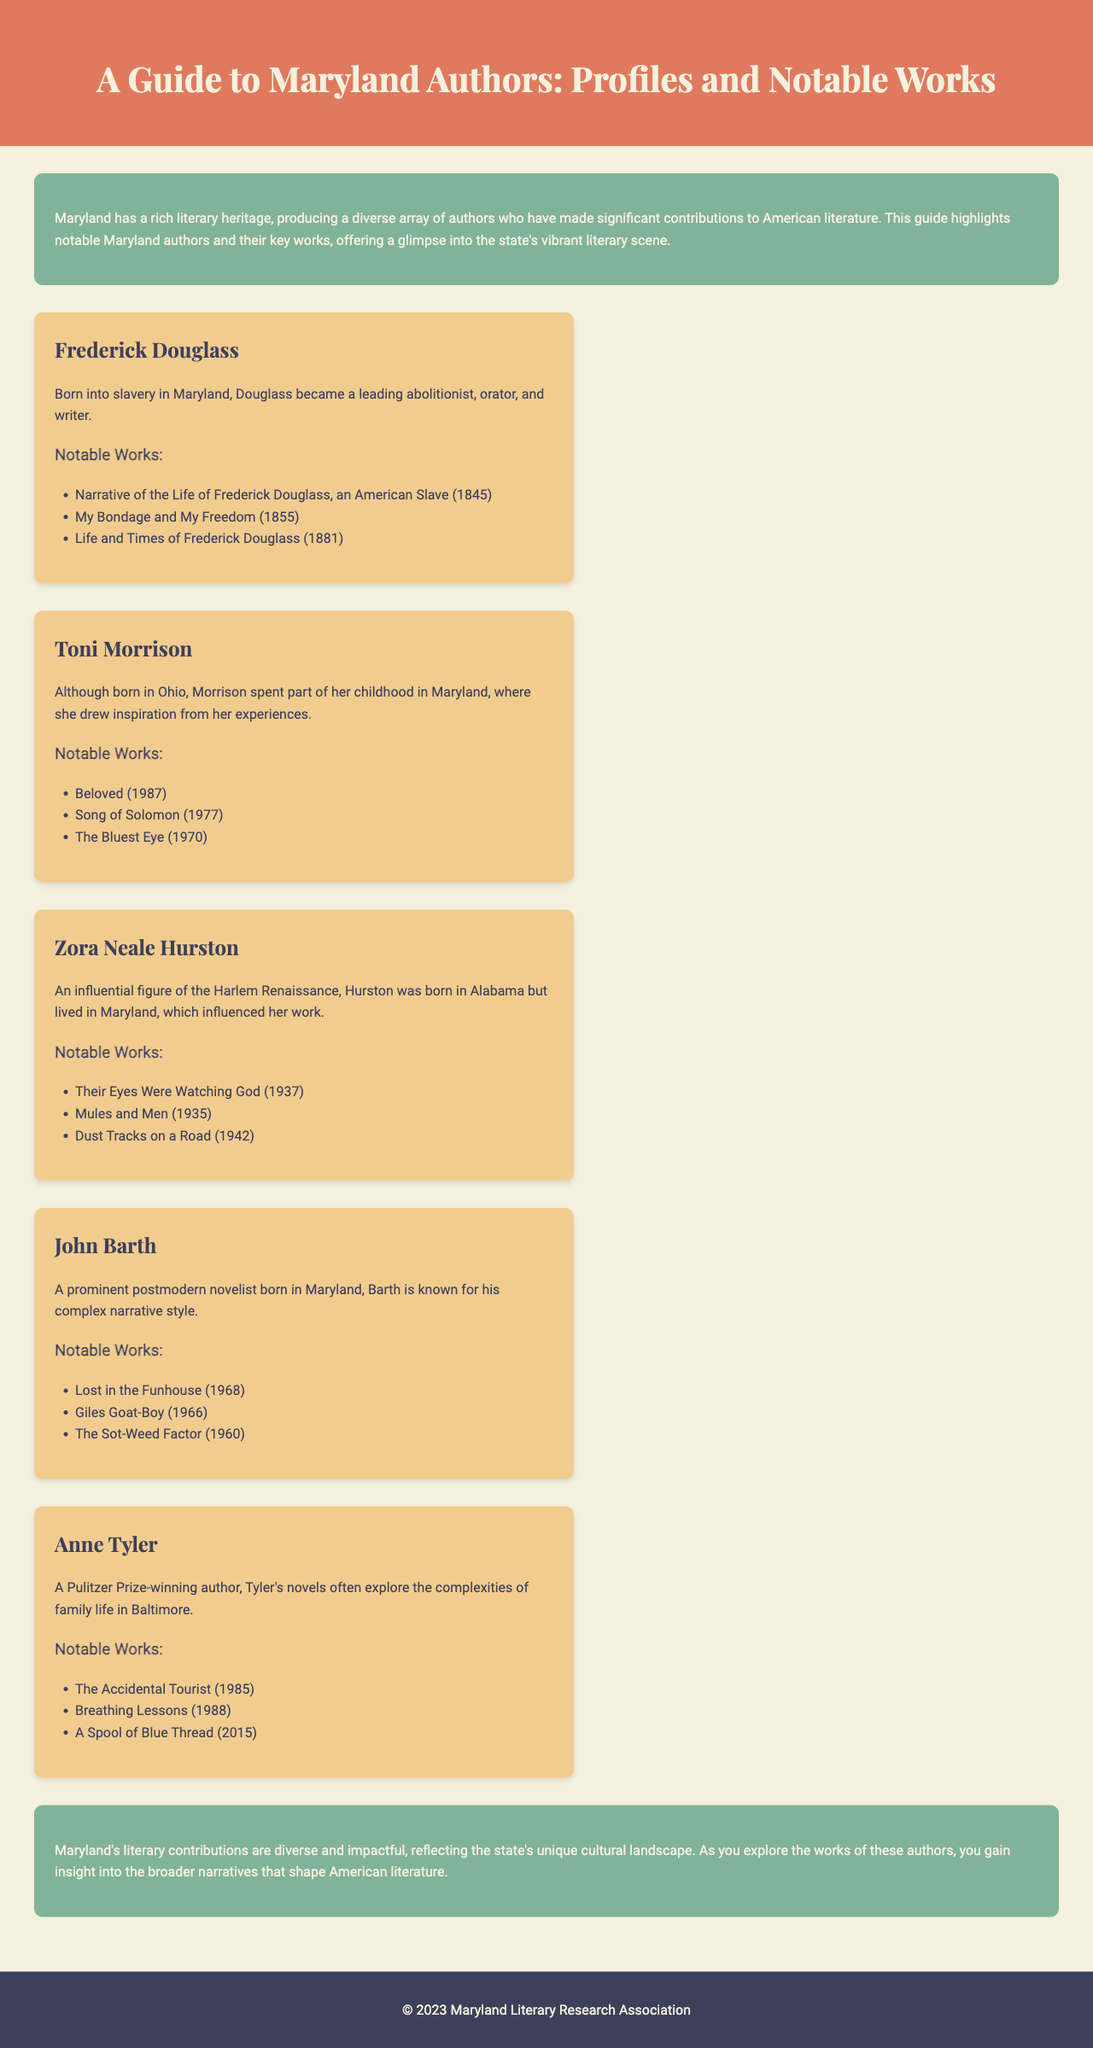What is the main theme of the brochure? The brochure highlights notable Maryland authors and their contributions to American literature.
Answer: Maryland authors and contributions Who is the author of "Beloved"? "Beloved" is one of the notable works listed under Toni Morrison.
Answer: Toni Morrison How many notable works are listed for Frederick Douglass? The document states three notable works for Frederick Douglass.
Answer: Three What year was "Their Eyes Were Watching God" published? The publication date for "Their Eyes Were Watching God" is provided as 1937.
Answer: 1937 Which author is known for "A Spool of Blue Thread"? The author associated with "A Spool of Blue Thread" is Anne Tyler.
Answer: Anne Tyler What significant literary period is Zora Neale Hurston associated with? Hurston is described as an influential figure of the Harlem Renaissance.
Answer: Harlem Renaissance How many Maryland authors are profiled in the brochure? There are five authors profiled in the document.
Answer: Five What type of work is "Lost in the Funhouse"? "Lost in the Funhouse" is classified as a novel and specifically a postmodern novel.
Answer: Postmodern novel 